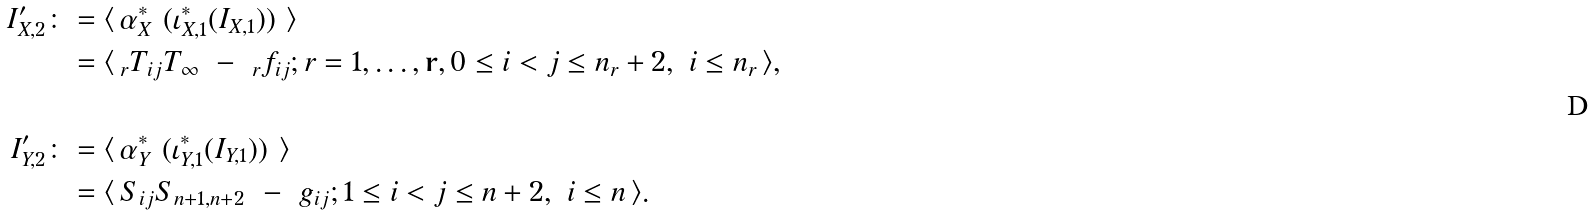Convert formula to latex. <formula><loc_0><loc_0><loc_500><loc_500>I ^ { \prime } _ { X , 2 } \colon & = \langle \, \alpha _ { X } ^ { * } \ ( \iota _ { X , 1 } ^ { * } ( I _ { X , 1 } ) ) \ \rangle \\ & = \langle \, _ { r } T _ { i j } T _ { \infty } \ - \ _ { r } f _ { i j } ; r = 1 , \dots , \mathbf r , 0 \leq i < j \leq n _ { r } + 2 , \ i \leq n _ { r } \, \rangle , \\ \\ I ^ { \prime } _ { Y , 2 } \colon & = \langle \, \alpha _ { Y } ^ { * } \ ( \iota _ { Y , 1 } ^ { * } ( I _ { Y , 1 } ) ) \ \rangle \\ & = \langle \, S _ { i j } S _ { n + 1 , n + 2 } \ - \ g _ { i j } ; 1 \leq i < j \leq n + 2 , \ i \leq n \, \rangle .</formula> 